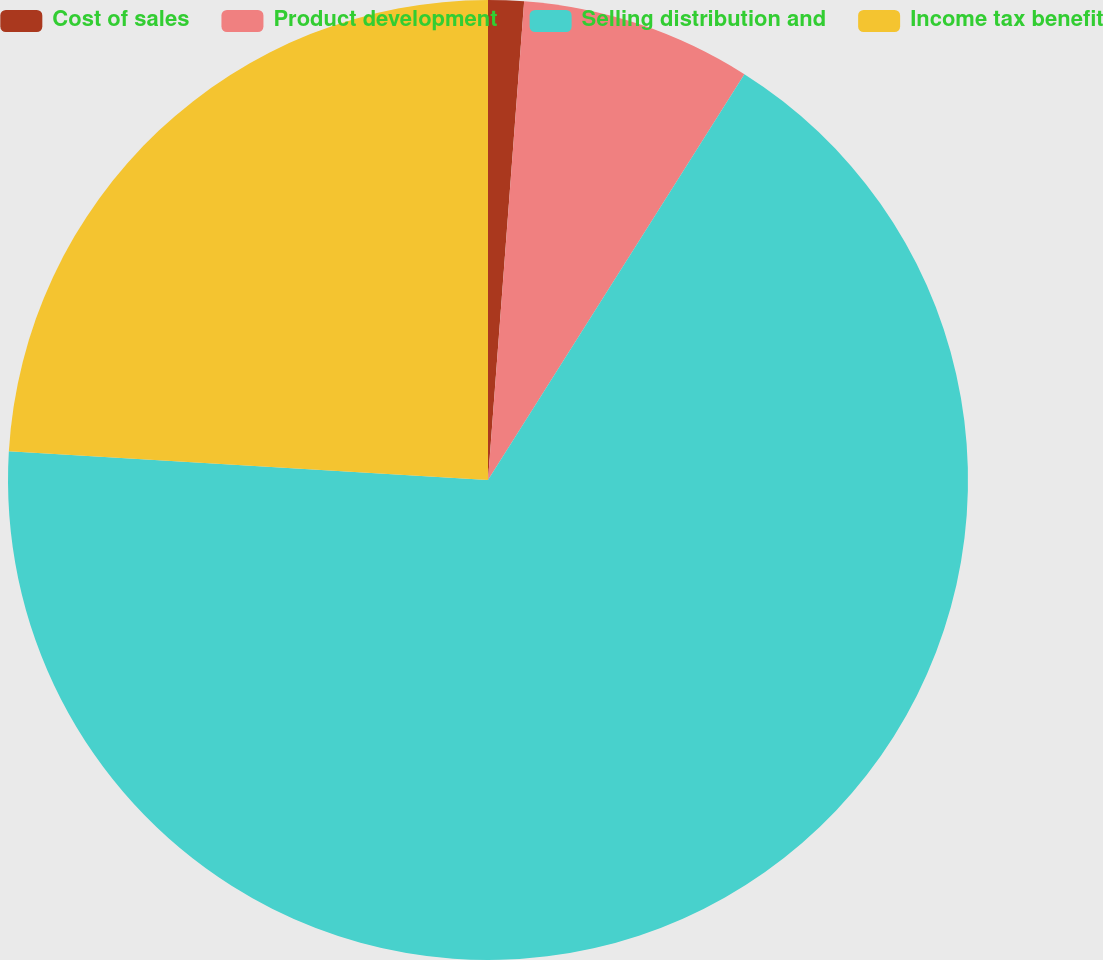Convert chart. <chart><loc_0><loc_0><loc_500><loc_500><pie_chart><fcel>Cost of sales<fcel>Product development<fcel>Selling distribution and<fcel>Income tax benefit<nl><fcel>1.2%<fcel>7.77%<fcel>66.98%<fcel>24.05%<nl></chart> 